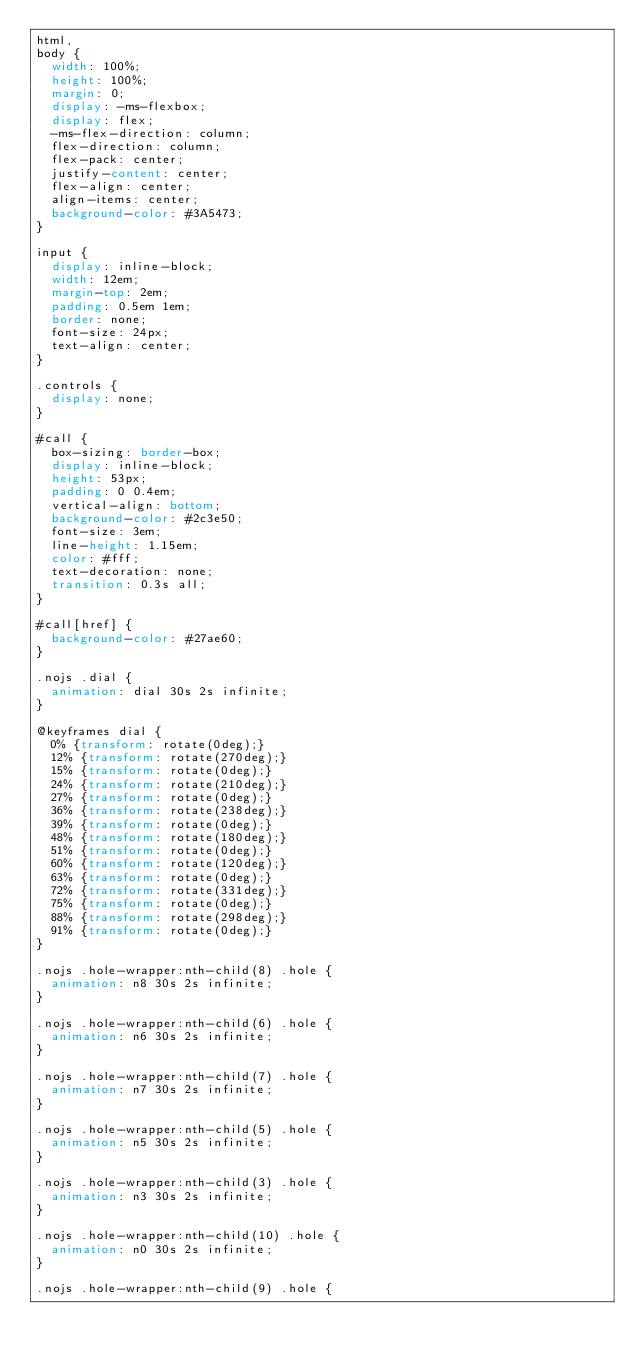<code> <loc_0><loc_0><loc_500><loc_500><_CSS_>html,
body {
  width: 100%;
  height: 100%;
  margin: 0;
  display: -ms-flexbox;
  display: flex;
  -ms-flex-direction: column;
  flex-direction: column;
  flex-pack: center;
  justify-content: center;
  flex-align: center;
  align-items: center;
  background-color: #3A5473;
}

input {
  display: inline-block;
  width: 12em;
  margin-top: 2em;
  padding: 0.5em 1em;
  border: none;
  font-size: 24px;
  text-align: center;
}

.controls {
  display: none;
}

#call {
  box-sizing: border-box;
  display: inline-block;
  height: 53px;
  padding: 0 0.4em;
  vertical-align: bottom;
  background-color: #2c3e50;
  font-size: 3em;
  line-height: 1.15em;
  color: #fff;
  text-decoration: none;
  transition: 0.3s all;
}

#call[href] {
  background-color: #27ae60;
}

.nojs .dial {
  animation: dial 30s 2s infinite;
}

@keyframes dial {
  0% {transform: rotate(0deg);}
  12% {transform: rotate(270deg);}
  15% {transform: rotate(0deg);}
  24% {transform: rotate(210deg);}
  27% {transform: rotate(0deg);}
  36% {transform: rotate(238deg);}
  39% {transform: rotate(0deg);}
  48% {transform: rotate(180deg);}
  51% {transform: rotate(0deg);}
  60% {transform: rotate(120deg);}
  63% {transform: rotate(0deg);}
  72% {transform: rotate(331deg);}
  75% {transform: rotate(0deg);}
  88% {transform: rotate(298deg);}
  91% {transform: rotate(0deg);}
}

.nojs .hole-wrapper:nth-child(8) .hole {
  animation: n8 30s 2s infinite;
}

.nojs .hole-wrapper:nth-child(6) .hole {
  animation: n6 30s 2s infinite;
}

.nojs .hole-wrapper:nth-child(7) .hole {
  animation: n7 30s 2s infinite;
}

.nojs .hole-wrapper:nth-child(5) .hole {
  animation: n5 30s 2s infinite;
}

.nojs .hole-wrapper:nth-child(3) .hole {
  animation: n3 30s 2s infinite;
}

.nojs .hole-wrapper:nth-child(10) .hole {
  animation: n0 30s 2s infinite;
}

.nojs .hole-wrapper:nth-child(9) .hole {</code> 